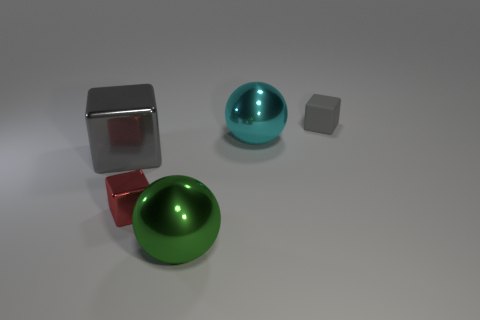Add 4 small brown spheres. How many objects exist? 9 Subtract all balls. How many objects are left? 3 Subtract 0 blue cylinders. How many objects are left? 5 Subtract all gray cubes. Subtract all large spheres. How many objects are left? 1 Add 5 small rubber blocks. How many small rubber blocks are left? 6 Add 5 large green objects. How many large green objects exist? 6 